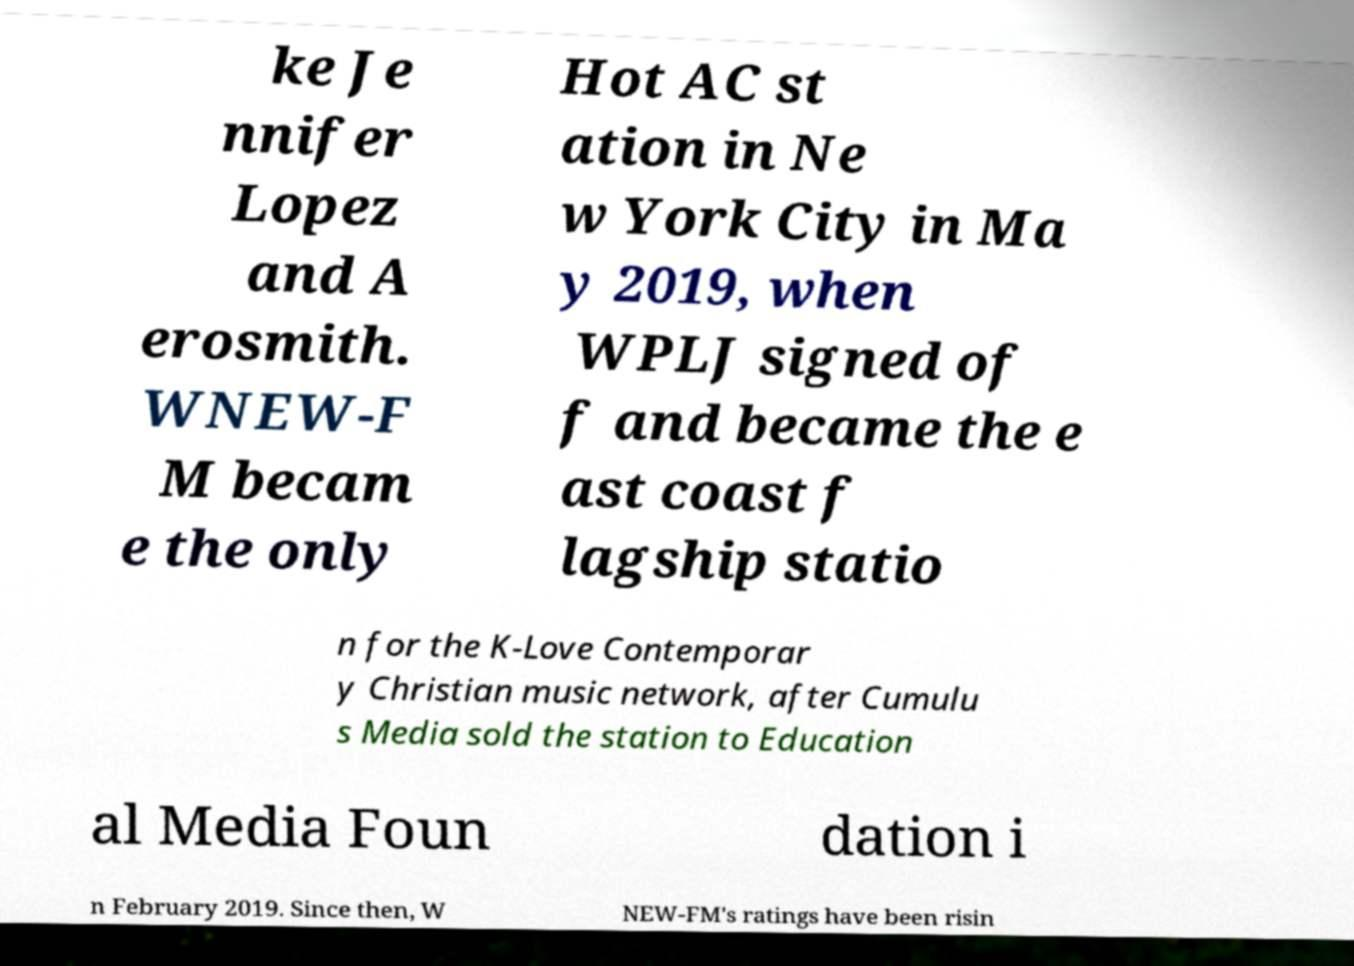Please identify and transcribe the text found in this image. ke Je nnifer Lopez and A erosmith. WNEW-F M becam e the only Hot AC st ation in Ne w York City in Ma y 2019, when WPLJ signed of f and became the e ast coast f lagship statio n for the K-Love Contemporar y Christian music network, after Cumulu s Media sold the station to Education al Media Foun dation i n February 2019. Since then, W NEW-FM's ratings have been risin 